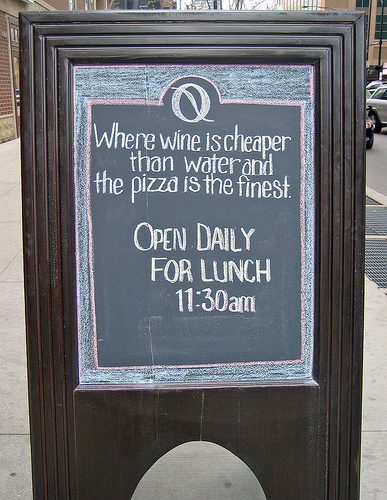<image>
Is there a sidewalk in front of the sign? No. The sidewalk is not in front of the sign. The spatial positioning shows a different relationship between these objects. 